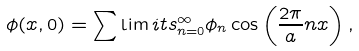Convert formula to latex. <formula><loc_0><loc_0><loc_500><loc_500>\phi ( x , 0 ) = \sum \lim i t s _ { n = 0 } ^ { \infty } \phi _ { n } \cos \left ( \frac { 2 \pi } { a } n x \right ) ,</formula> 